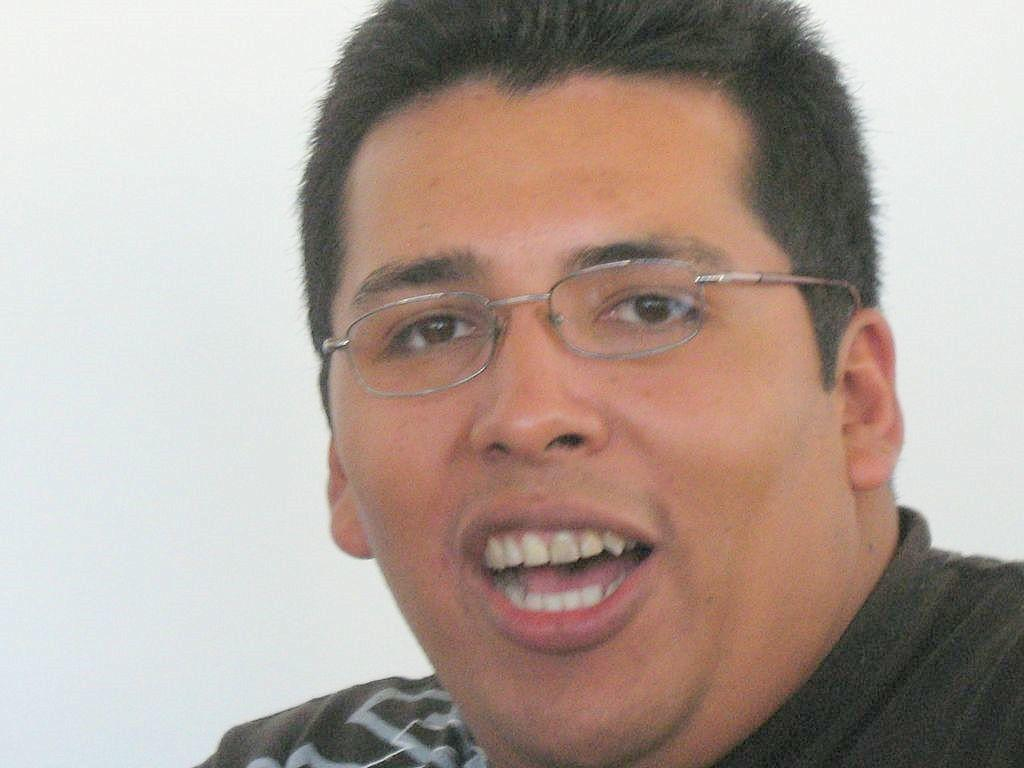Who or what is the main subject in the image? There is a person in the image. What can be observed about the person's appearance? The person is wearing spectacles. What might the person be doing in the image? The person appears to be talking. What is the color of the background in the image? The background of the image is white. Can you describe the ground or terrain in the image? There is no ground or terrain visible in the image, as the background is white and the focus is on the person. What type of country or region is depicted in the image? The image does not depict any specific country or region; it only shows a person with a white background. 